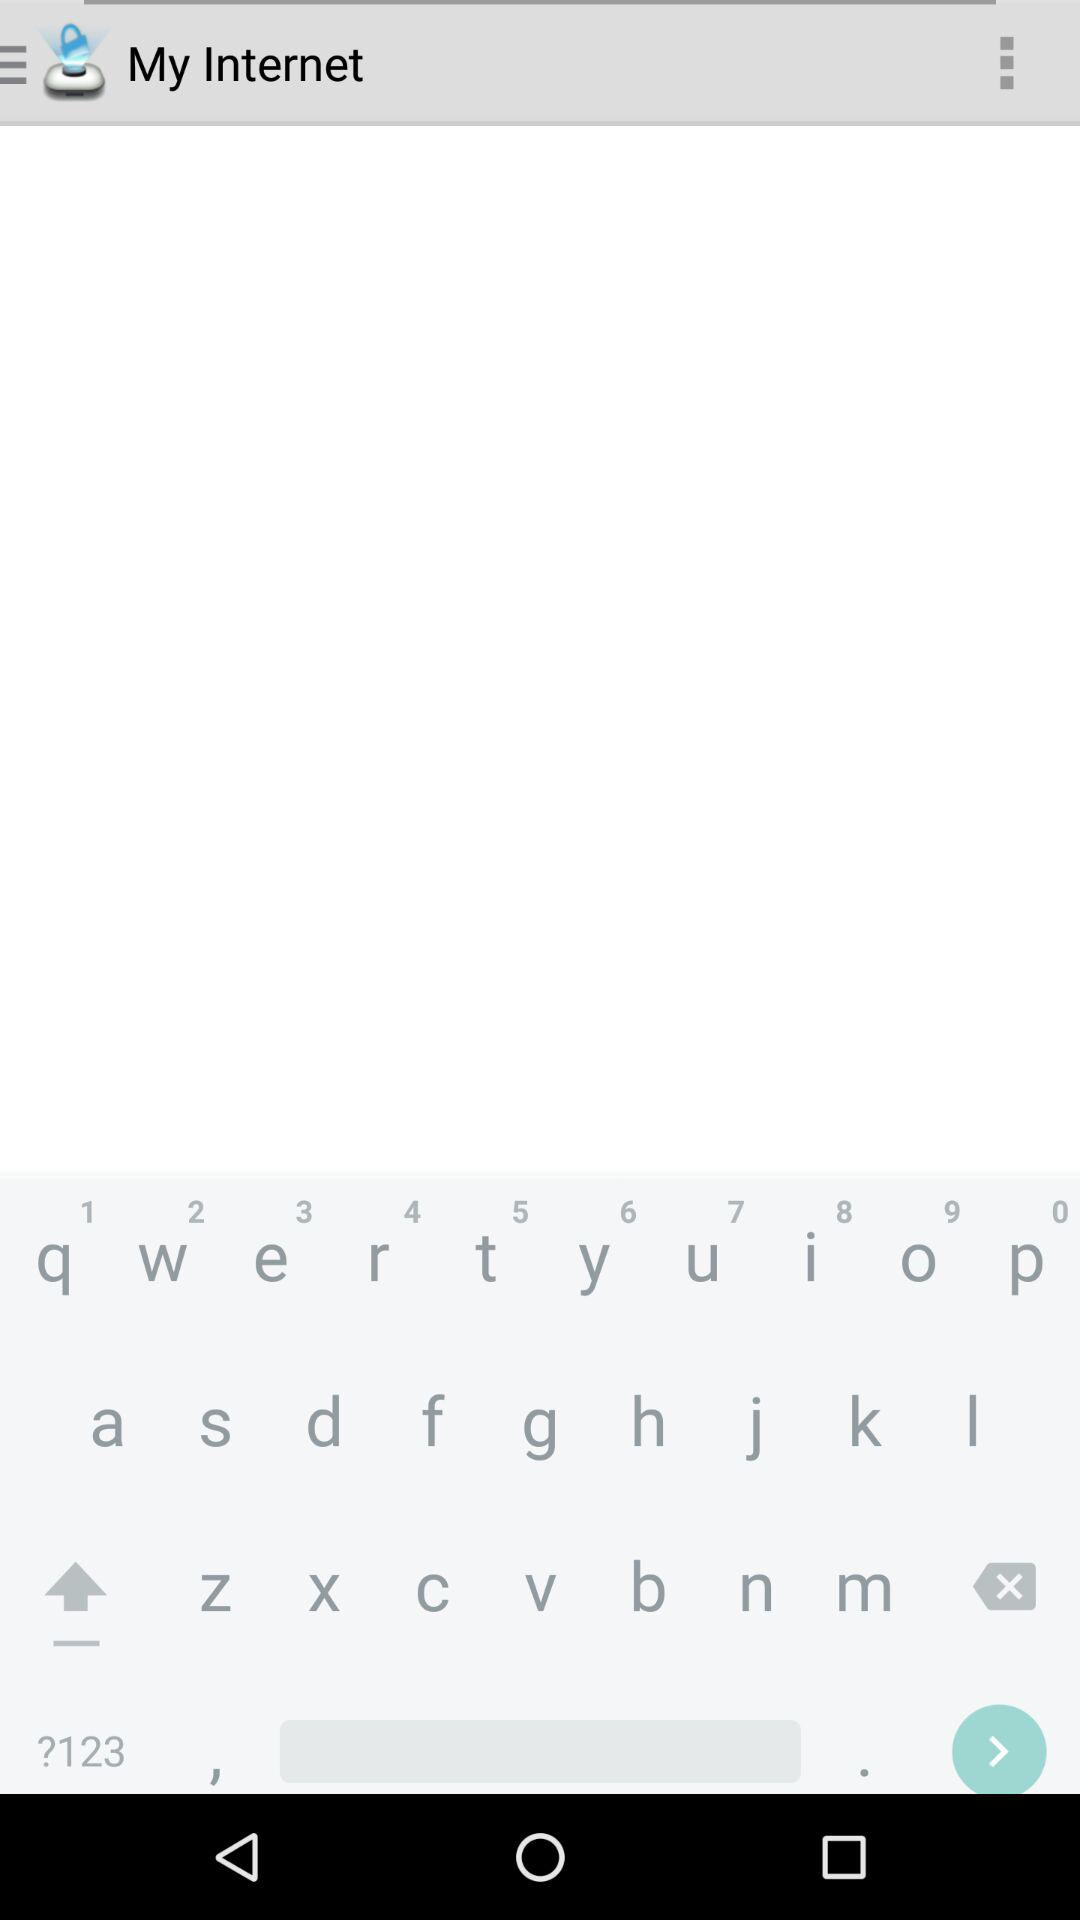Who is this application powered by?
When the provided information is insufficient, respond with <no answer>. <no answer> 